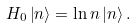<formula> <loc_0><loc_0><loc_500><loc_500>H _ { 0 } \left | n \right \rangle = \ln n \left | n \right \rangle .</formula> 